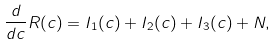Convert formula to latex. <formula><loc_0><loc_0><loc_500><loc_500>\frac { d } { d c } R ( c ) = I _ { 1 } ( c ) + I _ { 2 } ( c ) + I _ { 3 } ( c ) + N ,</formula> 